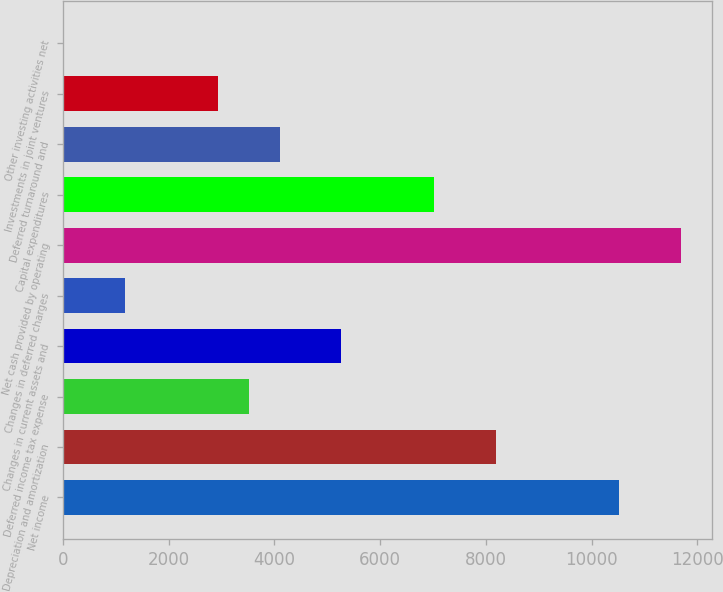Convert chart. <chart><loc_0><loc_0><loc_500><loc_500><bar_chart><fcel>Net income<fcel>Depreciation and amortization<fcel>Deferred income tax expense<fcel>Changes in current assets and<fcel>Changes in deferred charges<fcel>Net cash provided by operating<fcel>Capital expenditures<fcel>Deferred turnaround and<fcel>Investments in joint ventures<fcel>Other investing activities net<nl><fcel>10523.6<fcel>8186.8<fcel>3513.2<fcel>5265.8<fcel>1176.4<fcel>11692<fcel>7018.4<fcel>4097.4<fcel>2929<fcel>8<nl></chart> 